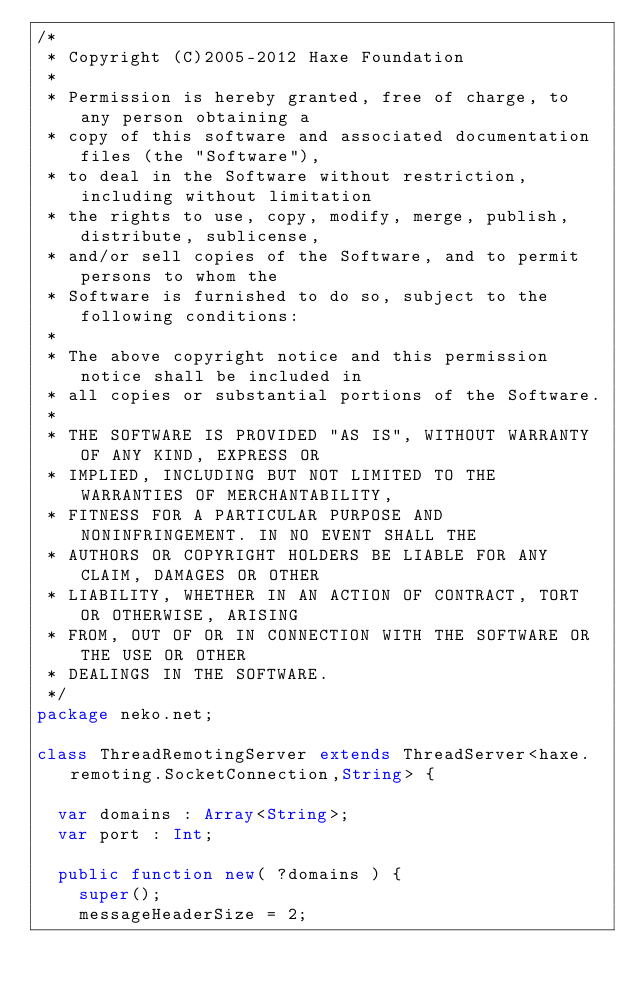<code> <loc_0><loc_0><loc_500><loc_500><_Haxe_>/*
 * Copyright (C)2005-2012 Haxe Foundation
 *
 * Permission is hereby granted, free of charge, to any person obtaining a
 * copy of this software and associated documentation files (the "Software"),
 * to deal in the Software without restriction, including without limitation
 * the rights to use, copy, modify, merge, publish, distribute, sublicense,
 * and/or sell copies of the Software, and to permit persons to whom the
 * Software is furnished to do so, subject to the following conditions:
 *
 * The above copyright notice and this permission notice shall be included in
 * all copies or substantial portions of the Software.
 *
 * THE SOFTWARE IS PROVIDED "AS IS", WITHOUT WARRANTY OF ANY KIND, EXPRESS OR
 * IMPLIED, INCLUDING BUT NOT LIMITED TO THE WARRANTIES OF MERCHANTABILITY,
 * FITNESS FOR A PARTICULAR PURPOSE AND NONINFRINGEMENT. IN NO EVENT SHALL THE
 * AUTHORS OR COPYRIGHT HOLDERS BE LIABLE FOR ANY CLAIM, DAMAGES OR OTHER
 * LIABILITY, WHETHER IN AN ACTION OF CONTRACT, TORT OR OTHERWISE, ARISING
 * FROM, OUT OF OR IN CONNECTION WITH THE SOFTWARE OR THE USE OR OTHER
 * DEALINGS IN THE SOFTWARE.
 */
package neko.net;

class ThreadRemotingServer extends ThreadServer<haxe.remoting.SocketConnection,String> {

	var domains : Array<String>;
	var port : Int;

	public function new( ?domains ) {
		super();
		messageHeaderSize = 2;</code> 